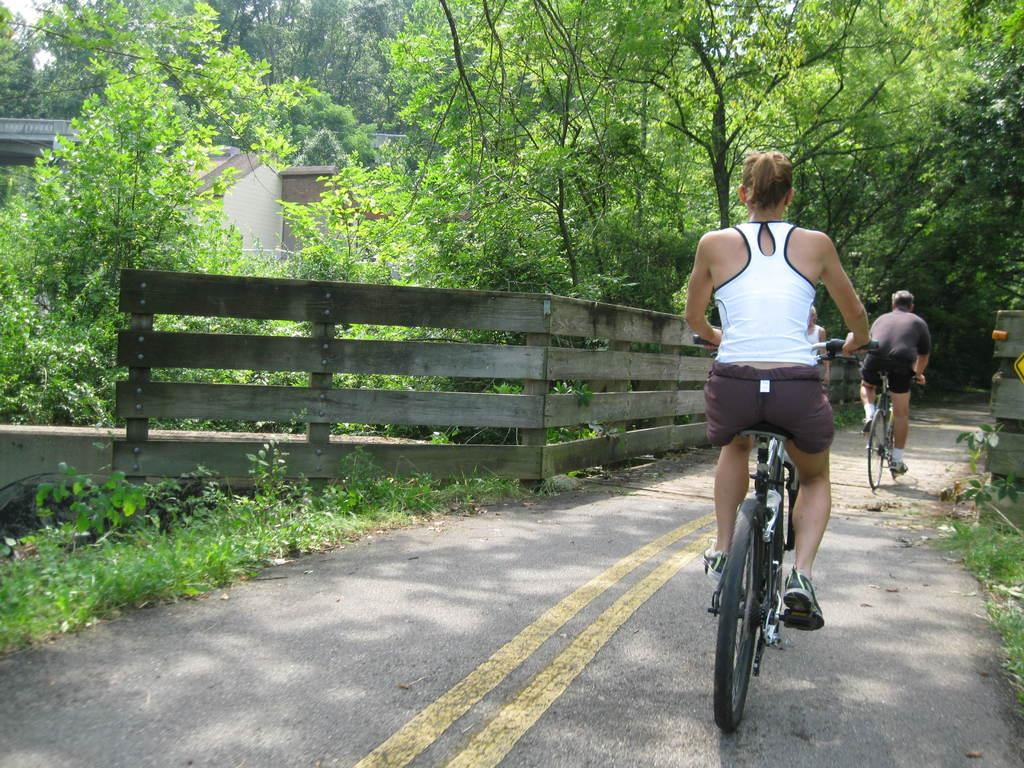What is the man in the image doing? The man is riding a bicycle in the image. What is the woman in the image doing? The woman is also riding a bicycle in the image. Where are the bicycles located? The bicycles are on a road in the image. What can be seen alongside the road? There is a wooden fence alongside the road in the image. What is visible in the background of the image? There are buildings and trees in the background of the image. What type of pie is being thrown during the fight in the image? There is no fight or pie present in the image; it features two people riding bicycles on a road. 